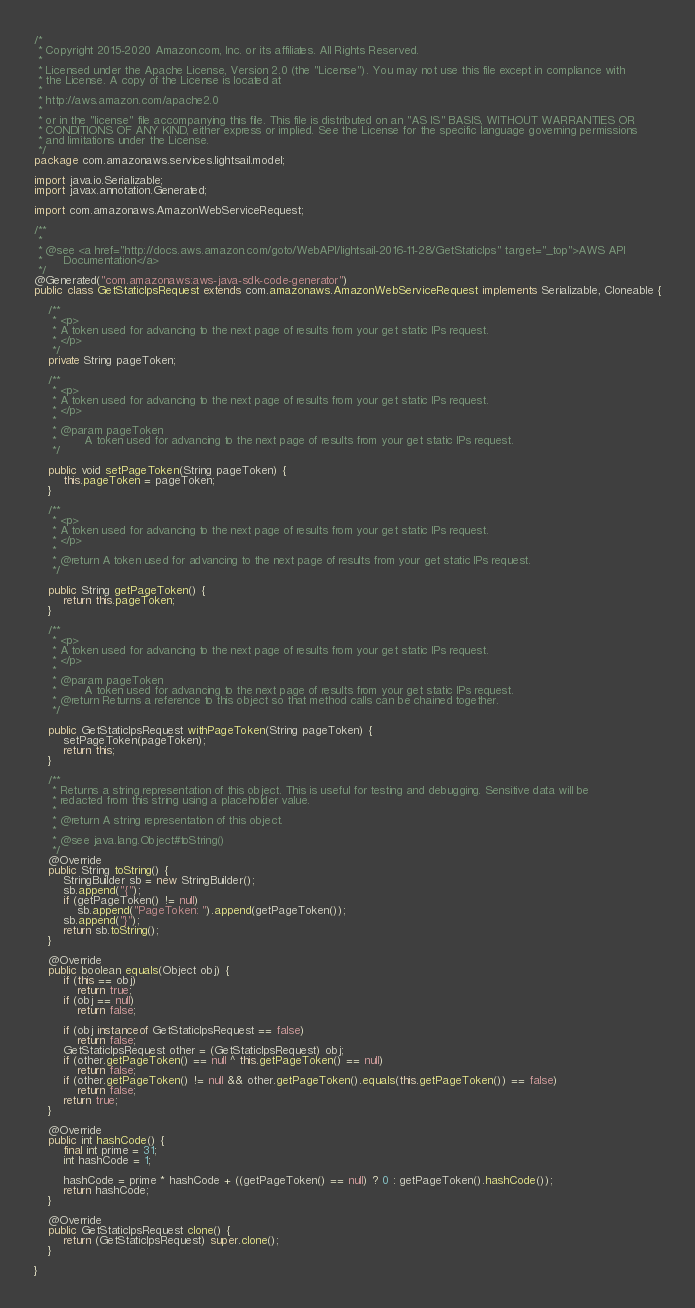Convert code to text. <code><loc_0><loc_0><loc_500><loc_500><_Java_>/*
 * Copyright 2015-2020 Amazon.com, Inc. or its affiliates. All Rights Reserved.
 * 
 * Licensed under the Apache License, Version 2.0 (the "License"). You may not use this file except in compliance with
 * the License. A copy of the License is located at
 * 
 * http://aws.amazon.com/apache2.0
 * 
 * or in the "license" file accompanying this file. This file is distributed on an "AS IS" BASIS, WITHOUT WARRANTIES OR
 * CONDITIONS OF ANY KIND, either express or implied. See the License for the specific language governing permissions
 * and limitations under the License.
 */
package com.amazonaws.services.lightsail.model;

import java.io.Serializable;
import javax.annotation.Generated;

import com.amazonaws.AmazonWebServiceRequest;

/**
 * 
 * @see <a href="http://docs.aws.amazon.com/goto/WebAPI/lightsail-2016-11-28/GetStaticIps" target="_top">AWS API
 *      Documentation</a>
 */
@Generated("com.amazonaws:aws-java-sdk-code-generator")
public class GetStaticIpsRequest extends com.amazonaws.AmazonWebServiceRequest implements Serializable, Cloneable {

    /**
     * <p>
     * A token used for advancing to the next page of results from your get static IPs request.
     * </p>
     */
    private String pageToken;

    /**
     * <p>
     * A token used for advancing to the next page of results from your get static IPs request.
     * </p>
     * 
     * @param pageToken
     *        A token used for advancing to the next page of results from your get static IPs request.
     */

    public void setPageToken(String pageToken) {
        this.pageToken = pageToken;
    }

    /**
     * <p>
     * A token used for advancing to the next page of results from your get static IPs request.
     * </p>
     * 
     * @return A token used for advancing to the next page of results from your get static IPs request.
     */

    public String getPageToken() {
        return this.pageToken;
    }

    /**
     * <p>
     * A token used for advancing to the next page of results from your get static IPs request.
     * </p>
     * 
     * @param pageToken
     *        A token used for advancing to the next page of results from your get static IPs request.
     * @return Returns a reference to this object so that method calls can be chained together.
     */

    public GetStaticIpsRequest withPageToken(String pageToken) {
        setPageToken(pageToken);
        return this;
    }

    /**
     * Returns a string representation of this object. This is useful for testing and debugging. Sensitive data will be
     * redacted from this string using a placeholder value.
     *
     * @return A string representation of this object.
     *
     * @see java.lang.Object#toString()
     */
    @Override
    public String toString() {
        StringBuilder sb = new StringBuilder();
        sb.append("{");
        if (getPageToken() != null)
            sb.append("PageToken: ").append(getPageToken());
        sb.append("}");
        return sb.toString();
    }

    @Override
    public boolean equals(Object obj) {
        if (this == obj)
            return true;
        if (obj == null)
            return false;

        if (obj instanceof GetStaticIpsRequest == false)
            return false;
        GetStaticIpsRequest other = (GetStaticIpsRequest) obj;
        if (other.getPageToken() == null ^ this.getPageToken() == null)
            return false;
        if (other.getPageToken() != null && other.getPageToken().equals(this.getPageToken()) == false)
            return false;
        return true;
    }

    @Override
    public int hashCode() {
        final int prime = 31;
        int hashCode = 1;

        hashCode = prime * hashCode + ((getPageToken() == null) ? 0 : getPageToken().hashCode());
        return hashCode;
    }

    @Override
    public GetStaticIpsRequest clone() {
        return (GetStaticIpsRequest) super.clone();
    }

}
</code> 